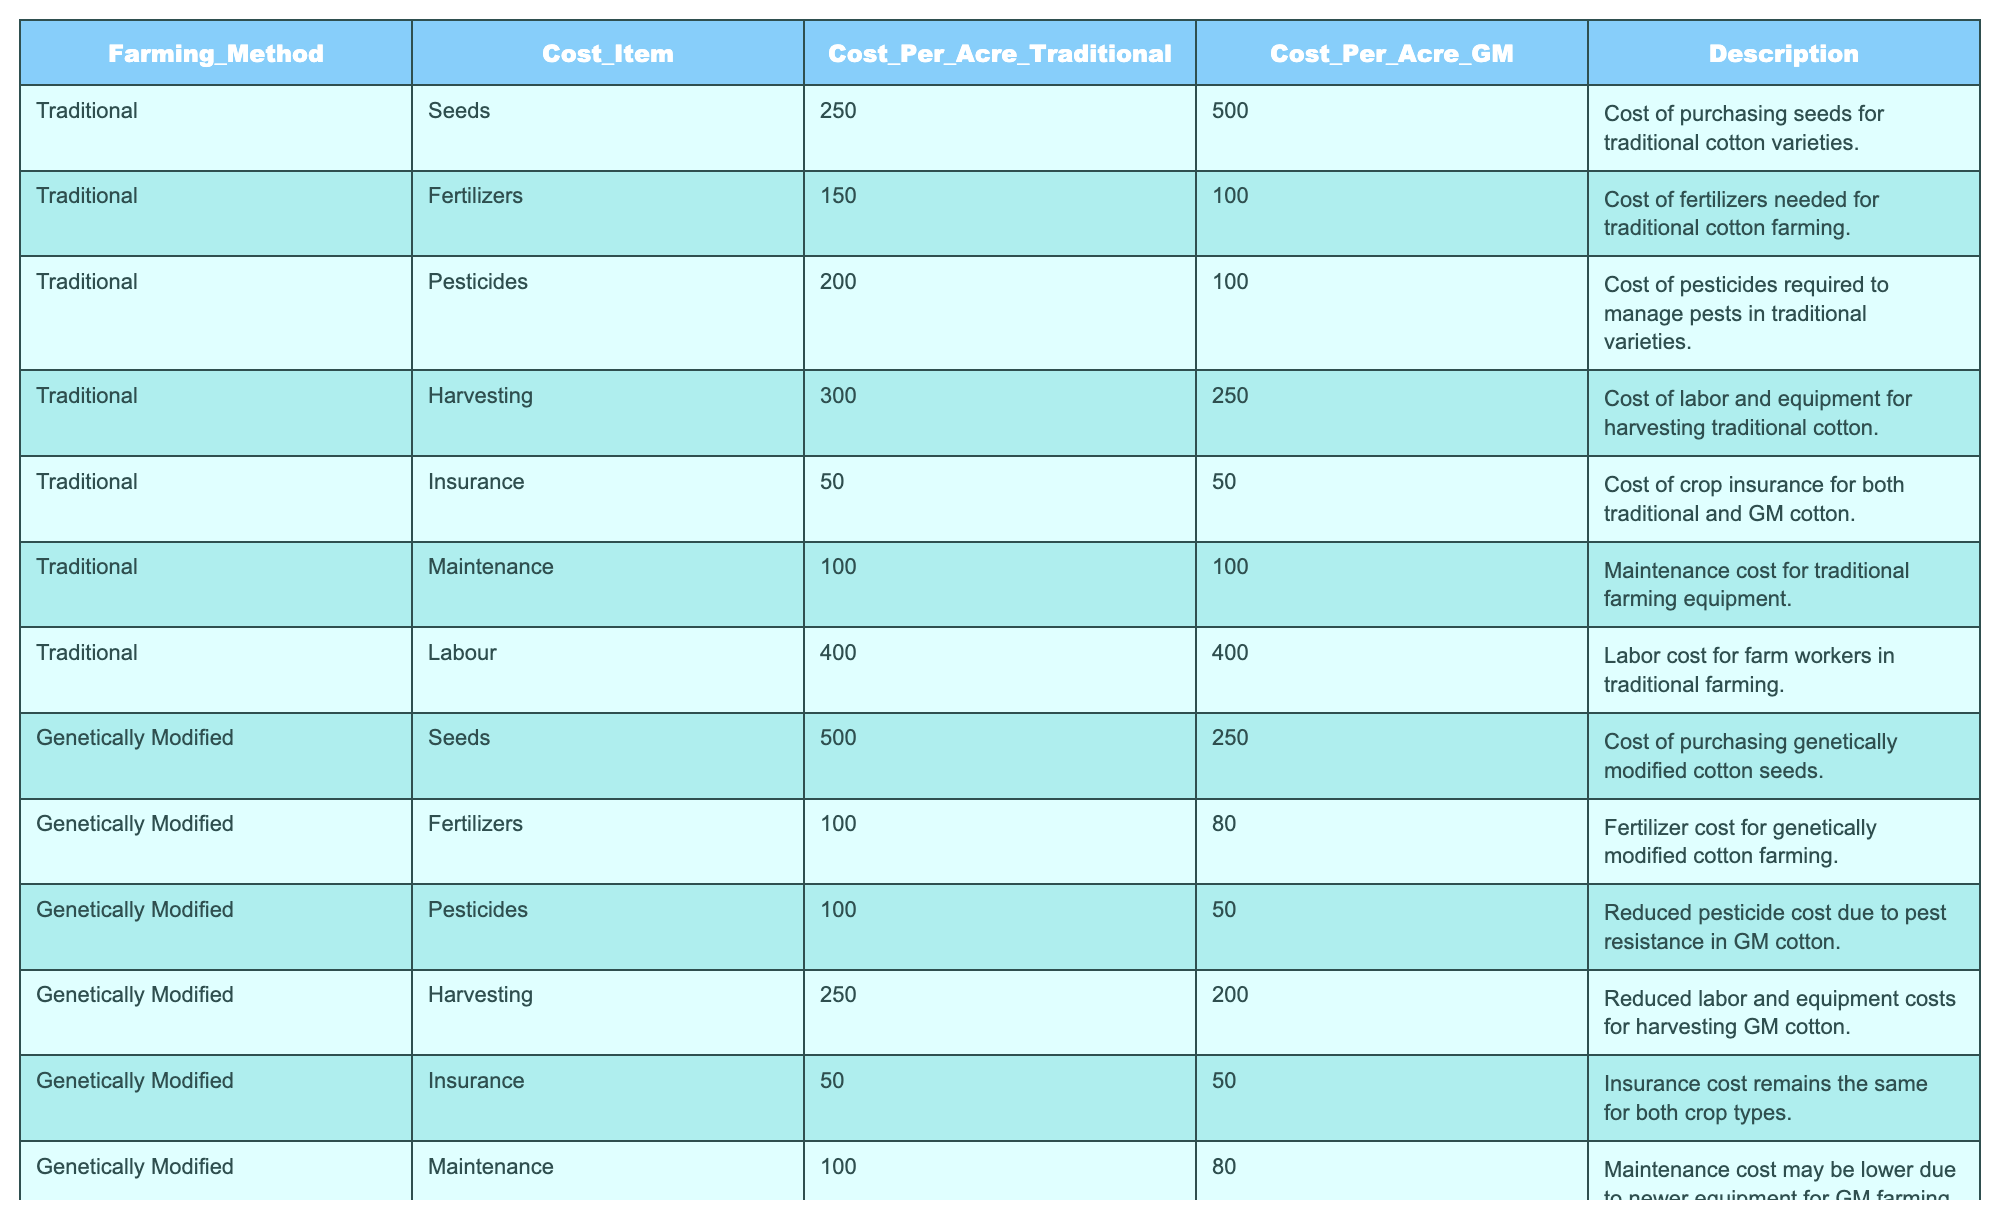What is the cost of seeds for traditional cotton farming? The table shows that the cost of seeds under traditional farming is listed as 250 per acre.
Answer: 250 What is the total cost of genetically modified cotton farming per acre? According to the table, the total cost of genetically modified cotton farming is given as 1200 per acre.
Answer: 1200 Is the cost of pesticides lower for genetically modified cotton? The cost of pesticides for genetically modified cotton is 50, which is lower than the traditional cost of 200.
Answer: Yes What is the difference in labor costs between traditional and genetically modified cotton farming? Traditional labor costs are listed as 400, while genetically modified labor costs are 350. The difference is calculated as 400 - 350 = 50.
Answer: 50 What is the average cost of fertilizers for both traditional and genetically modified cotton farming? The fertilizers cost for traditional cotton is 150, and for genetically modified cotton it is 100. To find the average, we sum them (150 + 100) = 250 and divide by 2, which gives us 250 / 2 = 125.
Answer: 125 Are the insurance costs the same for both types of cotton farming? Both traditional and genetically modified cotton farming have an insurance cost of 50, indicating they are the same.
Answer: Yes Which farming method has a higher total cost, and by how much? The total cost for traditional cotton is 1780 and for genetically modified it is 1200, so the difference is 1780 - 1200 = 580.
Answer: Traditional; 580 How much can a farmer save per acre by choosing genetically modified cotton over traditional cotton? The total cost of traditional cotton is 1780, while genetically modified cotton is 1200. The savings can be calculated as 1780 - 1200 = 580.
Answer: 580 Which cost item has the largest difference between traditional and genetically modified methods? Reviewing the cost items, seeds have a difference of 250 (500 for GM and 250 for traditional), which is greater than other categories.
Answer: Seeds What is the total cost of traditional methods for labor, maintenance, and harvesting? Adding labor (400), maintenance (100), and harvesting (300) gives us a total of 400 + 100 + 300 = 800.
Answer: 800 